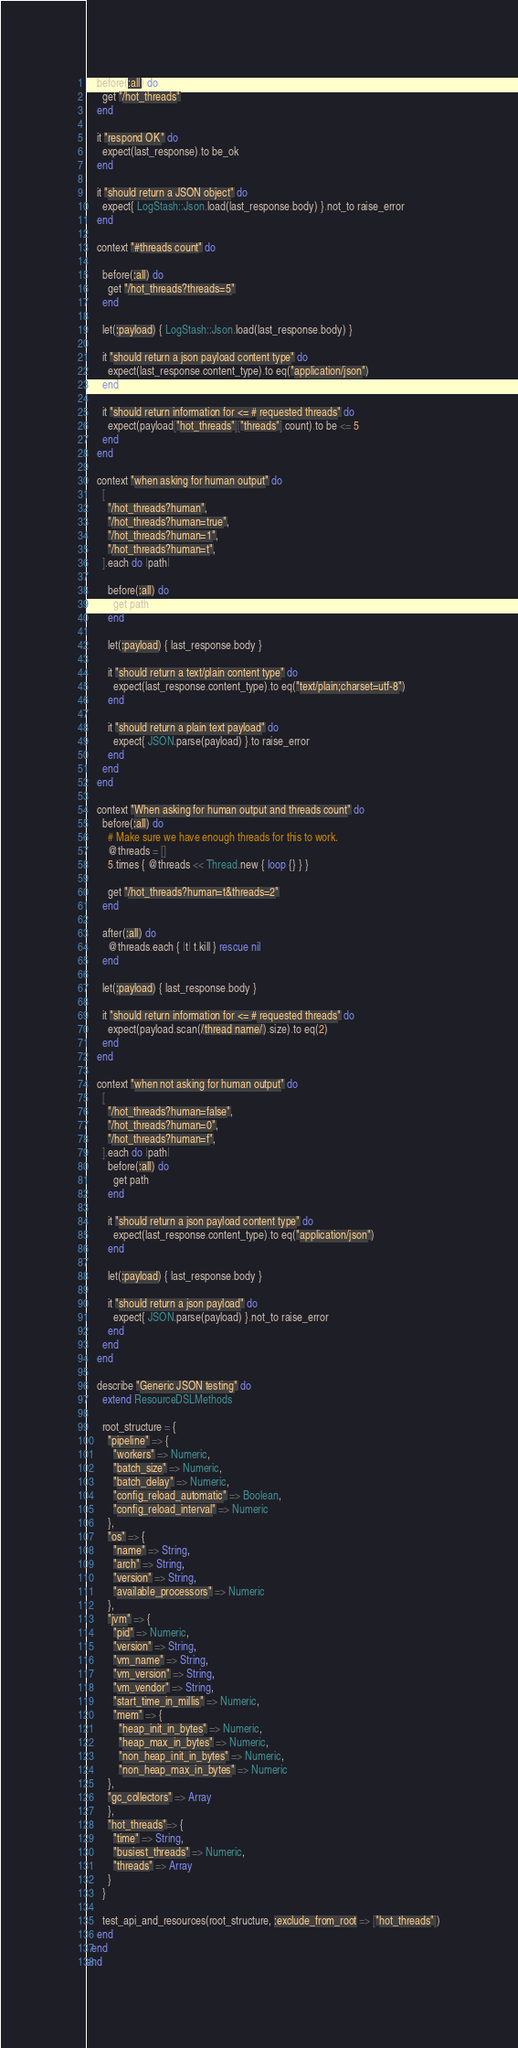<code> <loc_0><loc_0><loc_500><loc_500><_Ruby_>    before(:all) do
      get "/hot_threads"
    end

    it "respond OK" do
      expect(last_response).to be_ok
    end

    it "should return a JSON object" do
      expect{ LogStash::Json.load(last_response.body) }.not_to raise_error
    end

    context "#threads count" do

      before(:all) do
        get "/hot_threads?threads=5"
      end

      let(:payload) { LogStash::Json.load(last_response.body) }

      it "should return a json payload content type" do
        expect(last_response.content_type).to eq("application/json")
      end

      it "should return information for <= # requested threads" do
        expect(payload["hot_threads"]["threads"].count).to be <= 5
      end
    end

    context "when asking for human output" do
      [
        "/hot_threads?human",
        "/hot_threads?human=true",
        "/hot_threads?human=1",
        "/hot_threads?human=t",
      ].each do |path|

        before(:all) do
          get path
        end

        let(:payload) { last_response.body }

        it "should return a text/plain content type" do
          expect(last_response.content_type).to eq("text/plain;charset=utf-8")
        end

        it "should return a plain text payload" do
          expect{ JSON.parse(payload) }.to raise_error
        end
      end
    end

    context "When asking for human output and threads count" do
      before(:all) do
        # Make sure we have enough threads for this to work.
        @threads = []
        5.times { @threads << Thread.new { loop {} } }

        get "/hot_threads?human=t&threads=2"
      end

      after(:all) do
        @threads.each { |t| t.kill } rescue nil
      end

      let(:payload) { last_response.body }

      it "should return information for <= # requested threads" do
        expect(payload.scan(/thread name/).size).to eq(2)
      end
    end

    context "when not asking for human output" do
      [
        "/hot_threads?human=false",
        "/hot_threads?human=0",
        "/hot_threads?human=f",
      ].each do |path|
        before(:all) do
          get path
        end

        it "should return a json payload content type" do
          expect(last_response.content_type).to eq("application/json")
        end

        let(:payload) { last_response.body }

        it "should return a json payload" do
          expect{ JSON.parse(payload) }.not_to raise_error
        end
      end
    end

    describe "Generic JSON testing" do
      extend ResourceDSLMethods

      root_structure = {
        "pipeline" => {
          "workers" => Numeric,
          "batch_size" => Numeric,
          "batch_delay" => Numeric,
          "config_reload_automatic" => Boolean,
          "config_reload_interval" => Numeric
        },
        "os" => {
          "name" => String,
          "arch" => String,
          "version" => String,
          "available_processors" => Numeric
        },
        "jvm" => {
          "pid" => Numeric,
          "version" => String,
          "vm_name" => String,
          "vm_version" => String,
          "vm_vendor" => String,
          "start_time_in_millis" => Numeric,
          "mem" => {
            "heap_init_in_bytes" => Numeric,
            "heap_max_in_bytes" => Numeric,
            "non_heap_init_in_bytes" => Numeric,
            "non_heap_max_in_bytes" => Numeric
        },
        "gc_collectors" => Array
        },
        "hot_threads"=> {
          "time" => String,
          "busiest_threads" => Numeric,
          "threads" => Array
        }
      }

      test_api_and_resources(root_structure, :exclude_from_root => ["hot_threads"])
    end
  end
end
</code> 